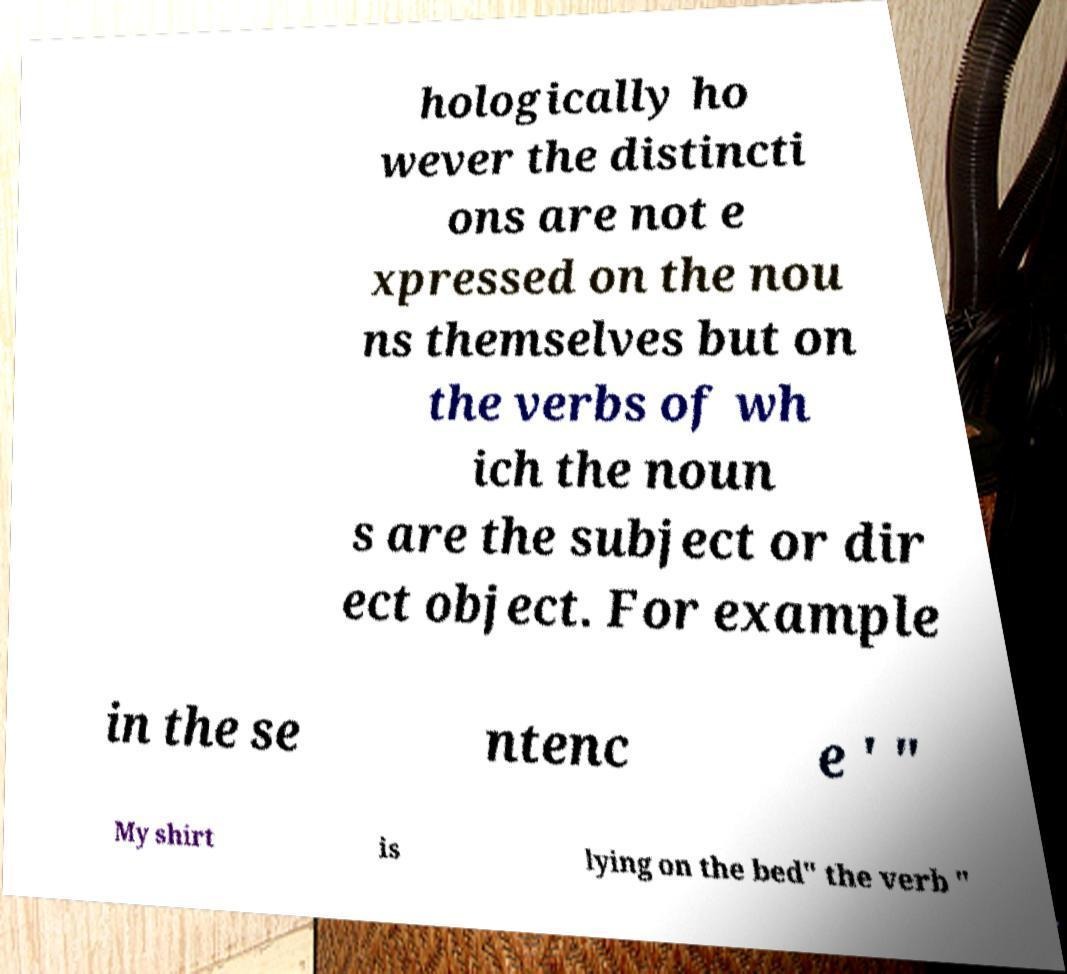Can you accurately transcribe the text from the provided image for me? hologically ho wever the distincti ons are not e xpressed on the nou ns themselves but on the verbs of wh ich the noun s are the subject or dir ect object. For example in the se ntenc e ' " My shirt is lying on the bed" the verb " 